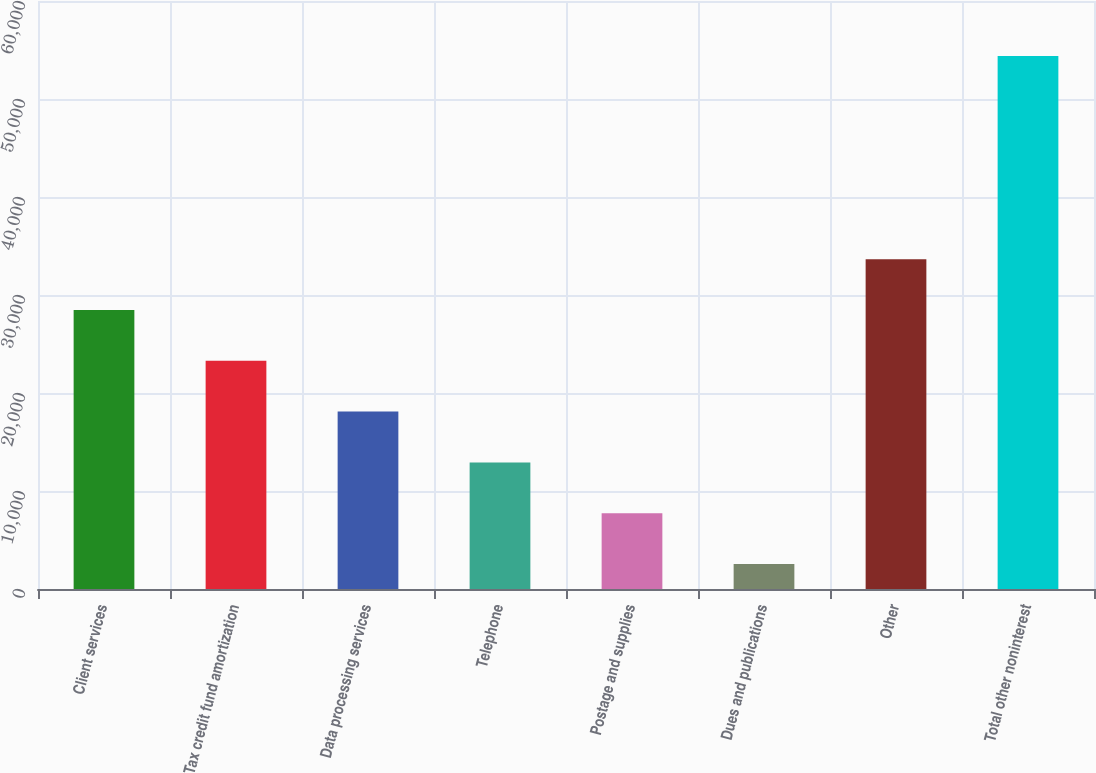Convert chart to OTSL. <chart><loc_0><loc_0><loc_500><loc_500><bar_chart><fcel>Client services<fcel>Tax credit fund amortization<fcel>Data processing services<fcel>Telephone<fcel>Postage and supplies<fcel>Dues and publications<fcel>Other<fcel>Total other noninterest<nl><fcel>28472.5<fcel>23287.8<fcel>18103.1<fcel>12918.4<fcel>7733.7<fcel>2549<fcel>33657.2<fcel>54396<nl></chart> 